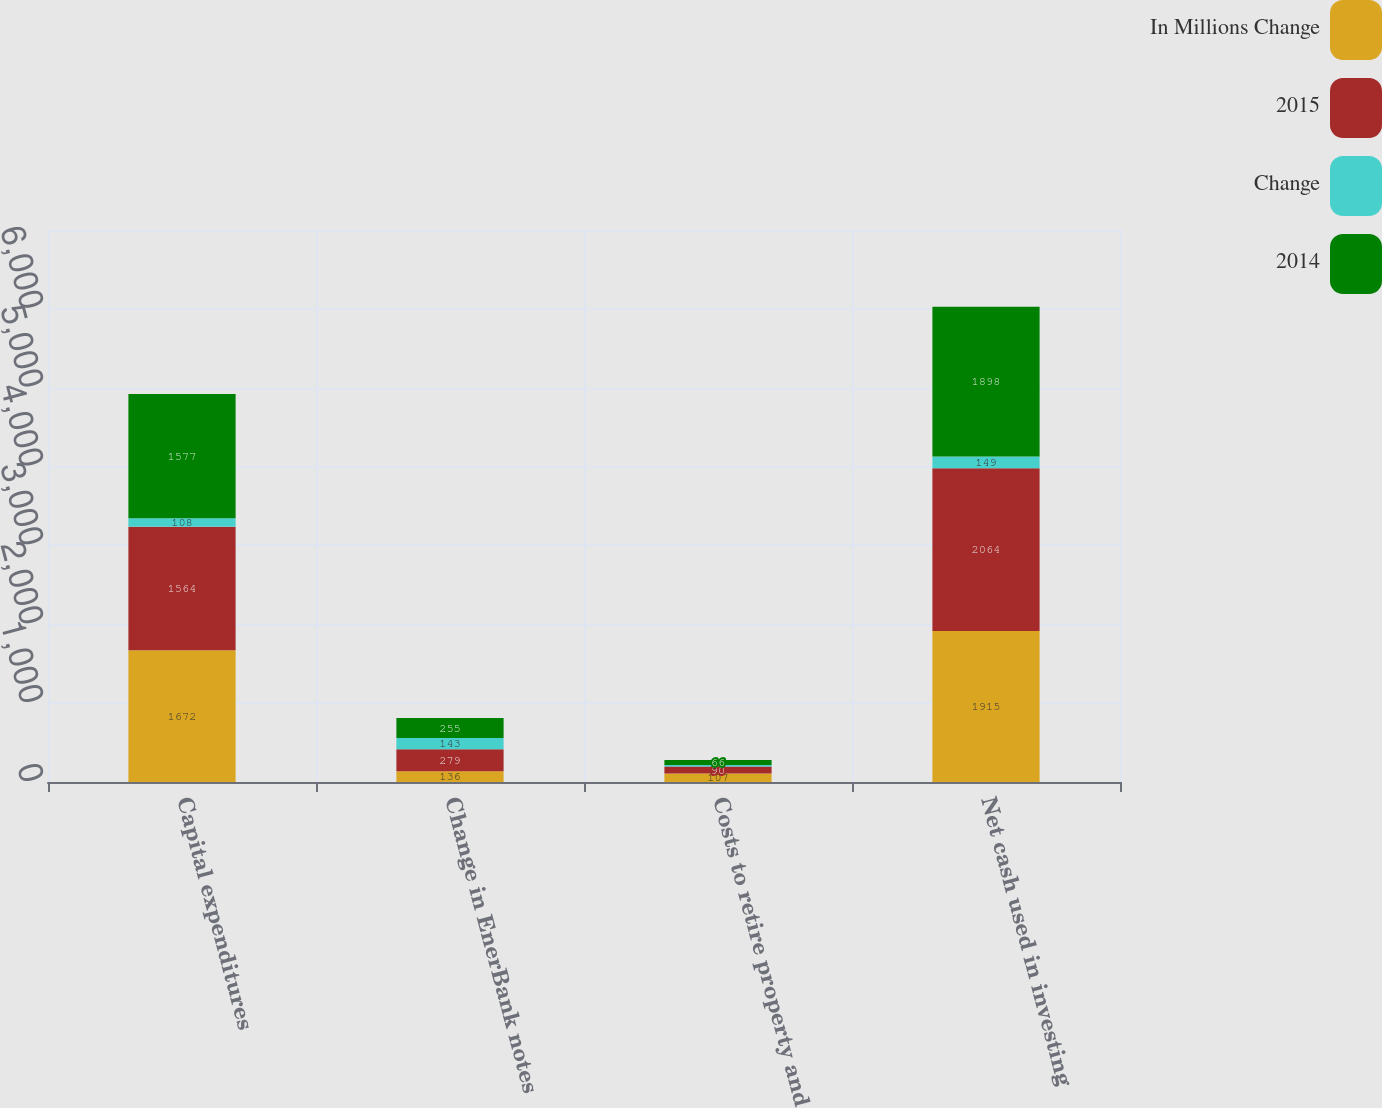Convert chart to OTSL. <chart><loc_0><loc_0><loc_500><loc_500><stacked_bar_chart><ecel><fcel>Capital expenditures<fcel>Change in EnerBank notes<fcel>Costs to retire property and<fcel>Net cash used in investing<nl><fcel>In Millions Change<fcel>1672<fcel>136<fcel>107<fcel>1915<nl><fcel>2015<fcel>1564<fcel>279<fcel>90<fcel>2064<nl><fcel>Change<fcel>108<fcel>143<fcel>17<fcel>149<nl><fcel>2014<fcel>1577<fcel>255<fcel>66<fcel>1898<nl></chart> 